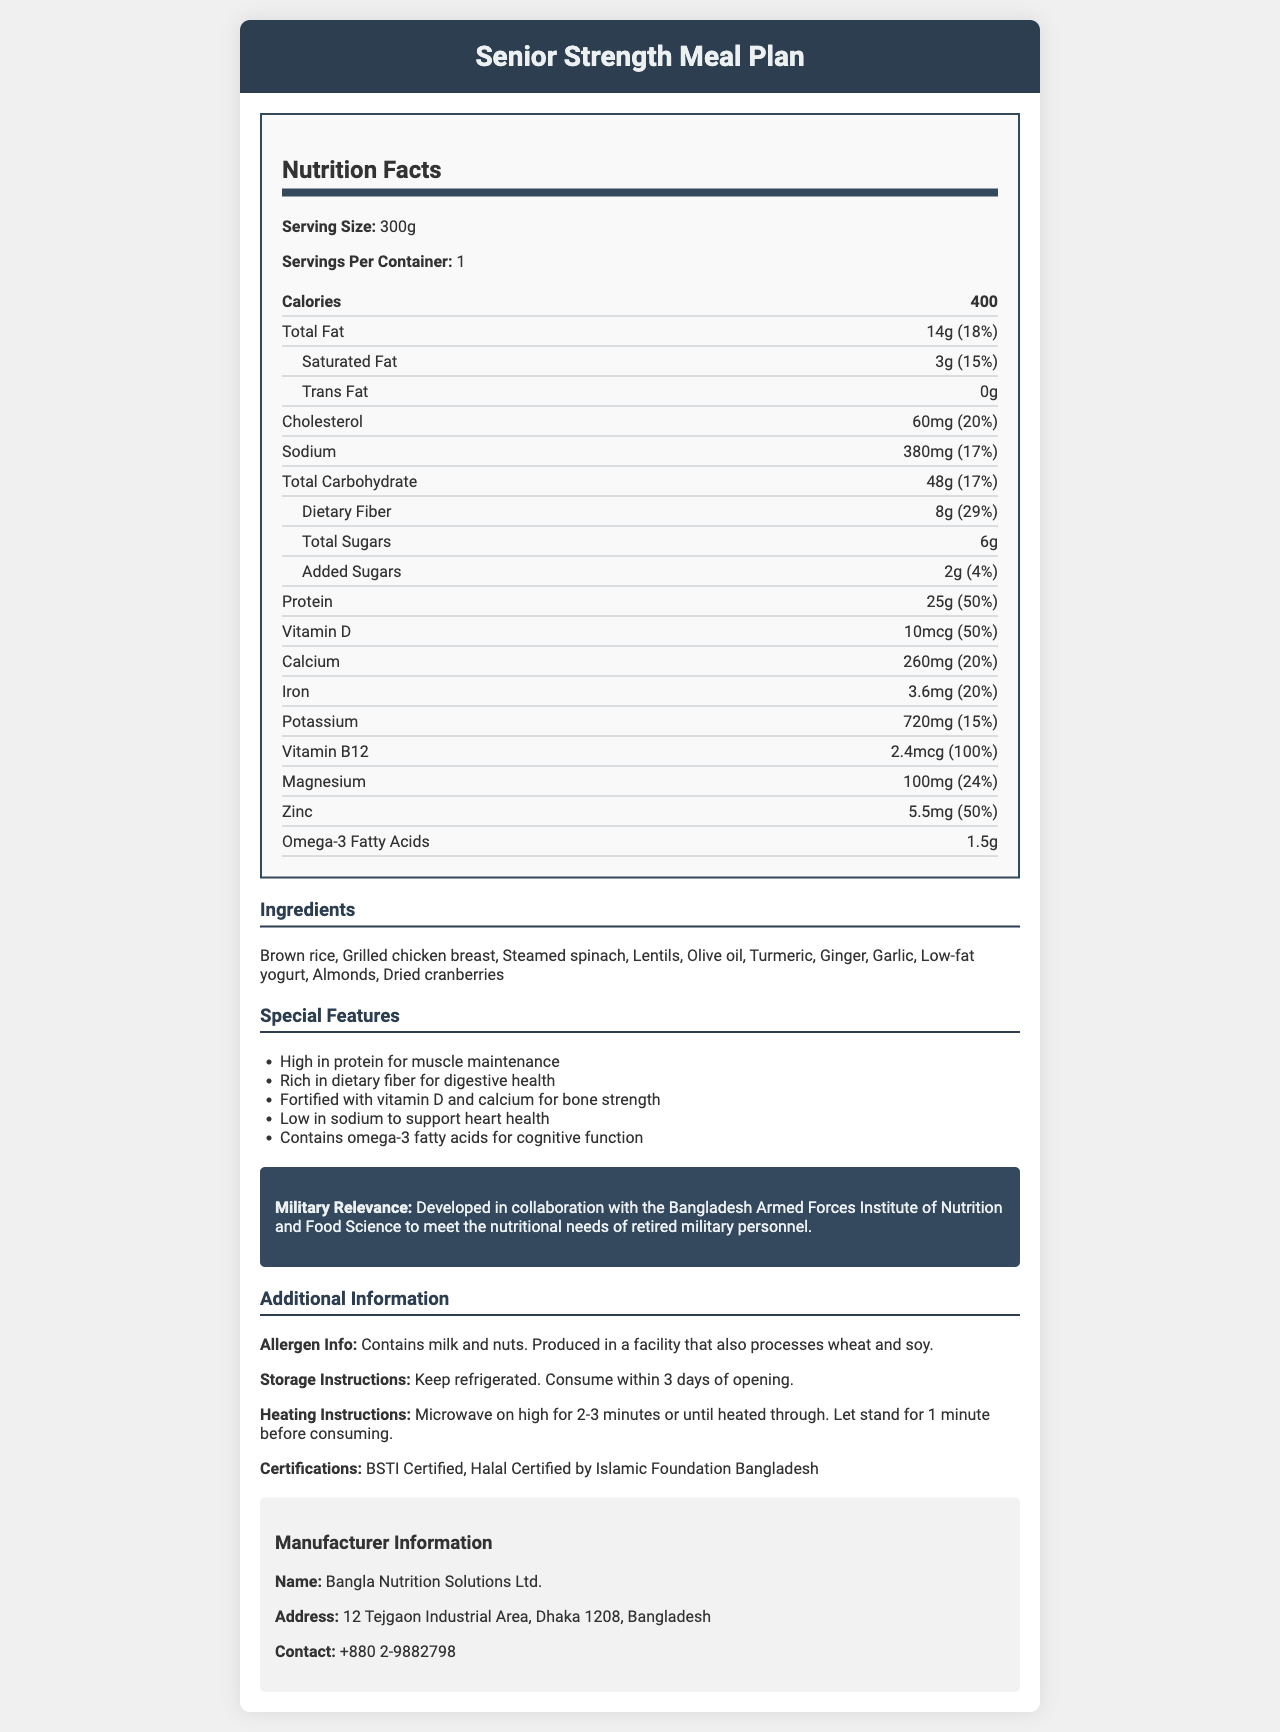what is the serving size? The serving size is labeled clearly as "Serving Size: 300g".
Answer: 300g how many servings are in each container? The document specifies "Servings Per Container: 1".
Answer: 1 how many calories are in a single serving? The nutrition label states "Calories: 400".
Answer: 400 calories List the amount and percent daily value of total fat. The "Total Fat" section lists 14g which is 18% of the daily value.
Answer: 14g, 18% How much dietary fiber does the meal contain? The "Dietary Fiber" section lists 8g which is 29% of the daily value.
Answer: 8g, 29% What is the amount of Omega-3 Fatty Acids in the meal? According to the nutrition label, the amount of Omega-3 Fatty Acids is 1.5g.
Answer: 1.5g Which of the following ingredients is included in the meal? A. Brown rice B. White rice C. Red Pepper D. Spinach The ingredients list includes Brown rice and Steamed spinach, but not the others.
Answer: A and D What is the percentage of daily value for Vitamin B12 per serving? A. 24% B. 50% C. 75% D. 100% The document states that the percent daily value of Vitamin B12 is 100%.
Answer: D Is this meal low in sodium? With 380mg of sodium, which is 17% of the daily value, this meal is considered low in sodium.
Answer: Yes Summarize the nutritional features of the "Senior Strength Meal Plan". The summary encompasses all the distinct nutritional benefits, ingredients included, and special collaborations mentioned in the document.
Answer: The "Senior Strength Meal Plan" targets senior citizens' nutritional needs including high protein for muscle maintenance, rich dietary fiber for digestive health, fortified with vitamin D and calcium for bone strength, low sodium for heart health, and contains omega-3 fatty acids for cognitive function. It includes ingredients like brown rice, grilled chicken breast, and almonds. It is developed in collaboration with the Bangladesh Armed Forces Institute of Nutrition and Food Science. Does the meal contain soy products? The document mentions that it's produced in a facility that processes soy, but it doesn't explicitly state if the meal contains soy products.
Answer: Cannot be determined 